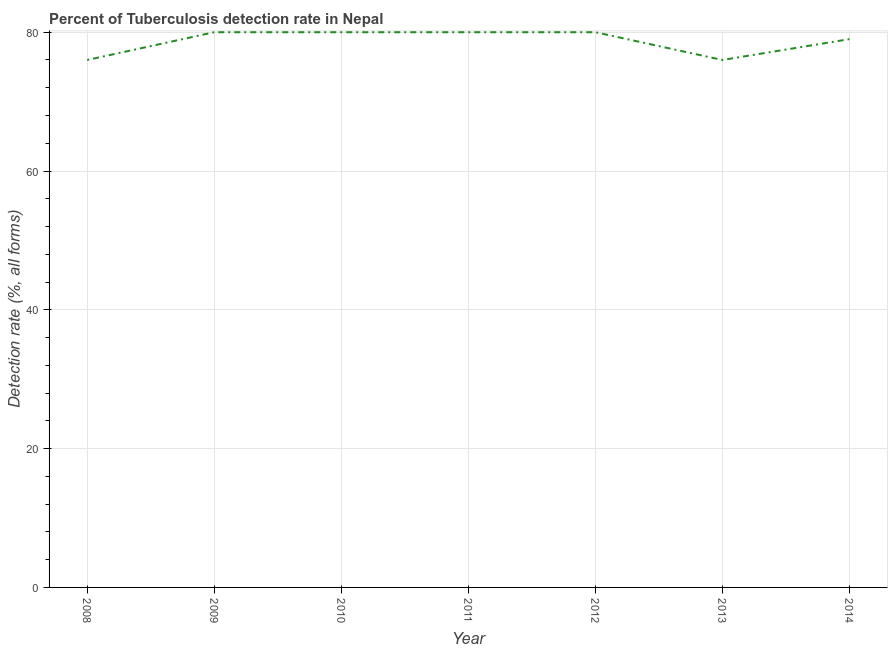What is the detection rate of tuberculosis in 2012?
Your answer should be compact. 80. Across all years, what is the maximum detection rate of tuberculosis?
Make the answer very short. 80. Across all years, what is the minimum detection rate of tuberculosis?
Offer a very short reply. 76. In which year was the detection rate of tuberculosis maximum?
Offer a very short reply. 2009. In which year was the detection rate of tuberculosis minimum?
Your answer should be very brief. 2008. What is the sum of the detection rate of tuberculosis?
Provide a succinct answer. 551. What is the difference between the detection rate of tuberculosis in 2009 and 2013?
Keep it short and to the point. 4. What is the average detection rate of tuberculosis per year?
Provide a succinct answer. 78.71. What is the median detection rate of tuberculosis?
Provide a short and direct response. 80. What is the ratio of the detection rate of tuberculosis in 2008 to that in 2009?
Offer a very short reply. 0.95. Is the detection rate of tuberculosis in 2008 less than that in 2014?
Ensure brevity in your answer.  Yes. Is the difference between the detection rate of tuberculosis in 2009 and 2013 greater than the difference between any two years?
Provide a succinct answer. Yes. What is the difference between the highest and the lowest detection rate of tuberculosis?
Ensure brevity in your answer.  4. In how many years, is the detection rate of tuberculosis greater than the average detection rate of tuberculosis taken over all years?
Provide a short and direct response. 5. How many lines are there?
Offer a terse response. 1. How many years are there in the graph?
Your answer should be very brief. 7. Are the values on the major ticks of Y-axis written in scientific E-notation?
Make the answer very short. No. Does the graph contain grids?
Give a very brief answer. Yes. What is the title of the graph?
Offer a very short reply. Percent of Tuberculosis detection rate in Nepal. What is the label or title of the X-axis?
Your answer should be very brief. Year. What is the label or title of the Y-axis?
Provide a short and direct response. Detection rate (%, all forms). What is the Detection rate (%, all forms) in 2008?
Provide a succinct answer. 76. What is the Detection rate (%, all forms) in 2009?
Your response must be concise. 80. What is the Detection rate (%, all forms) of 2012?
Keep it short and to the point. 80. What is the Detection rate (%, all forms) in 2014?
Ensure brevity in your answer.  79. What is the difference between the Detection rate (%, all forms) in 2008 and 2009?
Give a very brief answer. -4. What is the difference between the Detection rate (%, all forms) in 2008 and 2010?
Keep it short and to the point. -4. What is the difference between the Detection rate (%, all forms) in 2008 and 2011?
Provide a succinct answer. -4. What is the difference between the Detection rate (%, all forms) in 2008 and 2012?
Your answer should be very brief. -4. What is the difference between the Detection rate (%, all forms) in 2008 and 2013?
Ensure brevity in your answer.  0. What is the difference between the Detection rate (%, all forms) in 2009 and 2010?
Your answer should be very brief. 0. What is the difference between the Detection rate (%, all forms) in 2009 and 2011?
Give a very brief answer. 0. What is the difference between the Detection rate (%, all forms) in 2009 and 2013?
Give a very brief answer. 4. What is the difference between the Detection rate (%, all forms) in 2009 and 2014?
Give a very brief answer. 1. What is the difference between the Detection rate (%, all forms) in 2010 and 2011?
Provide a succinct answer. 0. What is the difference between the Detection rate (%, all forms) in 2010 and 2014?
Give a very brief answer. 1. What is the difference between the Detection rate (%, all forms) in 2011 and 2013?
Make the answer very short. 4. What is the difference between the Detection rate (%, all forms) in 2011 and 2014?
Offer a terse response. 1. What is the difference between the Detection rate (%, all forms) in 2013 and 2014?
Your answer should be very brief. -3. What is the ratio of the Detection rate (%, all forms) in 2008 to that in 2010?
Provide a short and direct response. 0.95. What is the ratio of the Detection rate (%, all forms) in 2008 to that in 2012?
Provide a short and direct response. 0.95. What is the ratio of the Detection rate (%, all forms) in 2009 to that in 2012?
Offer a terse response. 1. What is the ratio of the Detection rate (%, all forms) in 2009 to that in 2013?
Provide a succinct answer. 1.05. What is the ratio of the Detection rate (%, all forms) in 2010 to that in 2012?
Keep it short and to the point. 1. What is the ratio of the Detection rate (%, all forms) in 2010 to that in 2013?
Provide a short and direct response. 1.05. What is the ratio of the Detection rate (%, all forms) in 2011 to that in 2013?
Your response must be concise. 1.05. What is the ratio of the Detection rate (%, all forms) in 2012 to that in 2013?
Your answer should be very brief. 1.05. What is the ratio of the Detection rate (%, all forms) in 2012 to that in 2014?
Ensure brevity in your answer.  1.01. 